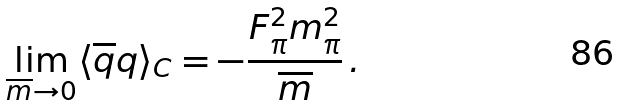Convert formula to latex. <formula><loc_0><loc_0><loc_500><loc_500>\lim _ { \overline { m } \to 0 } \langle \overline { q } q \rangle _ { C } = - \frac { F _ { \pi } ^ { 2 } m _ { \pi } ^ { 2 } } { \overline { m } } \, .</formula> 